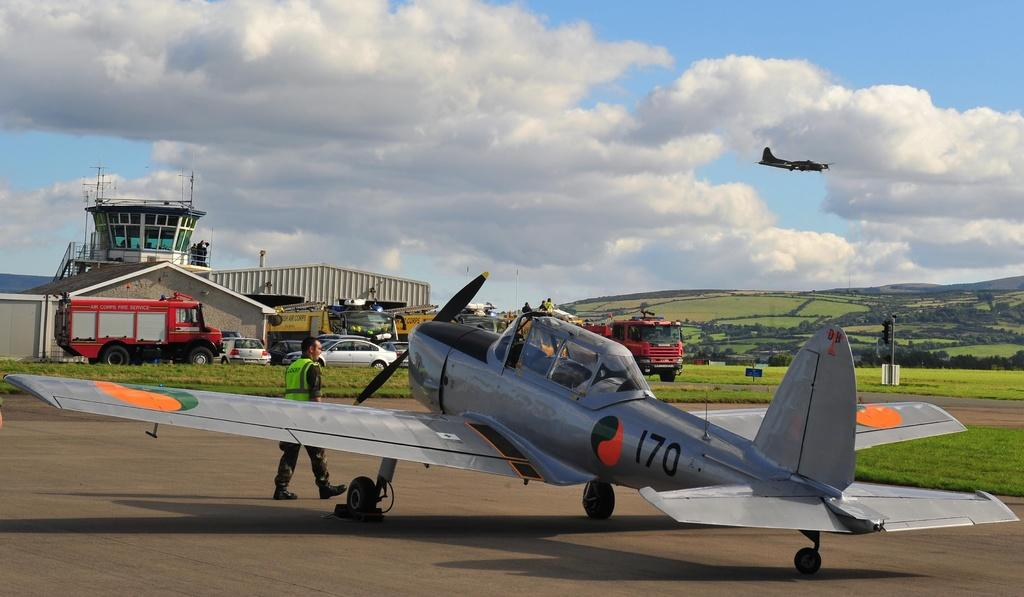<image>
Create a compact narrative representing the image presented. A grey airplane with the number 170 on it is parked at an airport. 